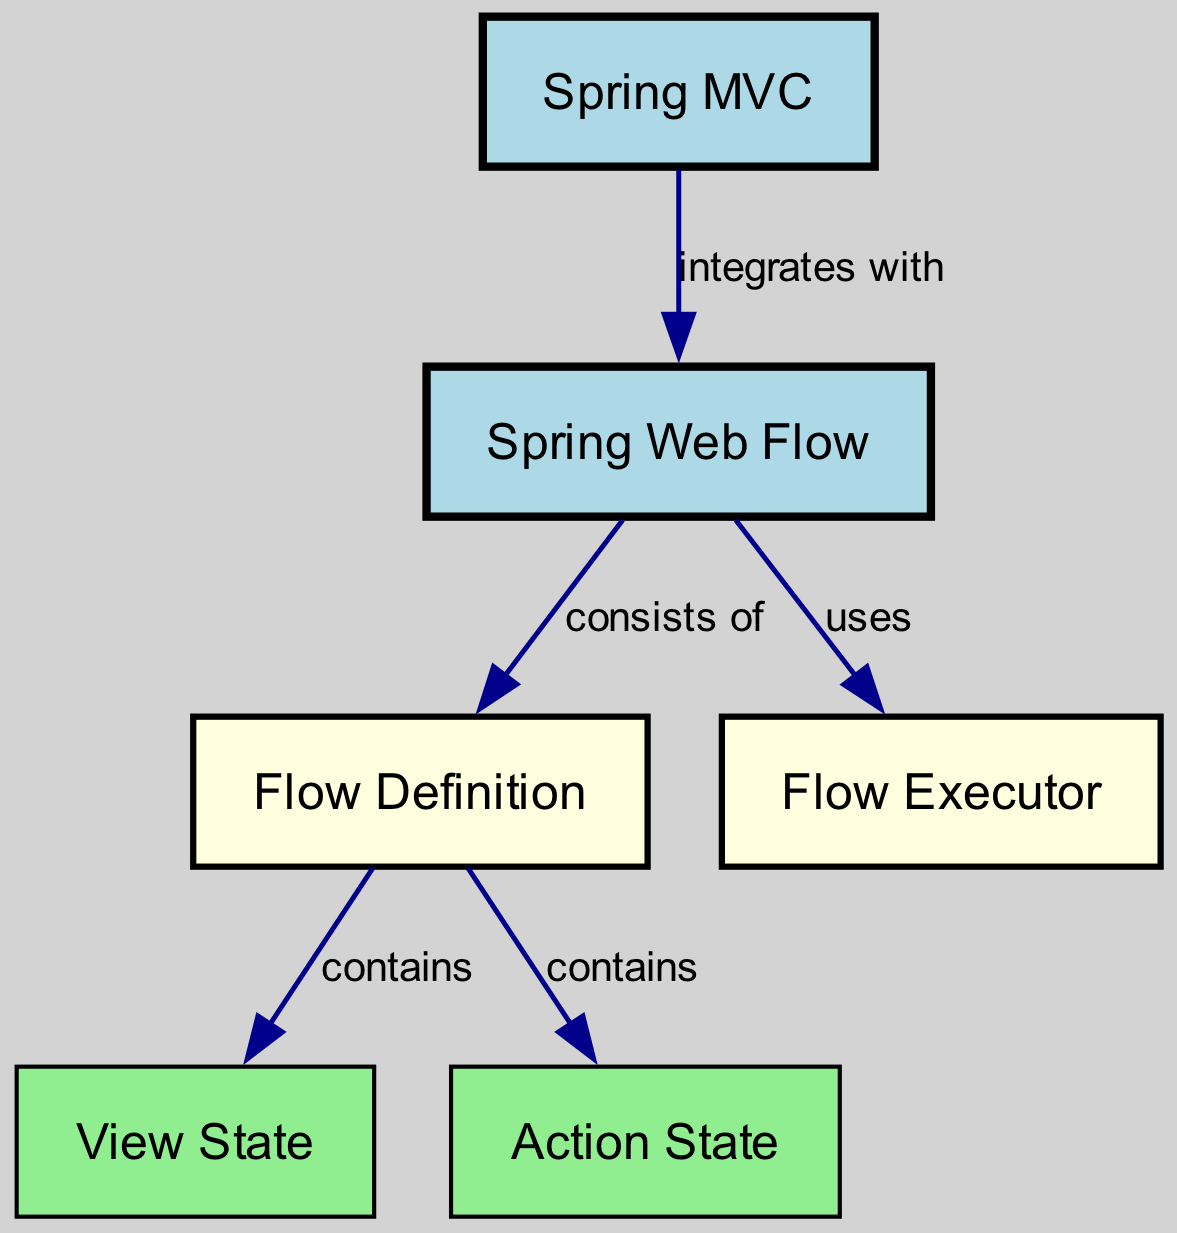What is the main component that integrates with Spring MVC? In the diagram, there is an edge labeled "integrates with" that connects the node "Spring MVC" to the node "Spring Web Flow." Hence, the main component that integrates is "Spring Web Flow."
Answer: Spring Web Flow How many nodes are present in the diagram? The diagram lists six nodes: "Spring MVC," "Spring Web Flow," "Flow Definition," "Flow Executor," "View State," and "Action State." Therefore, the total number of nodes is six.
Answer: 6 Which node is contained within the Flow Definition? The diagram shows two edges originating from "Flow Definition," labeled "contains," leading to "View State" and "Action State." Therefore, both "View State" and "Action State" are contained within the "Flow Definition."
Answer: View State and Action State What is the relationship between Spring Web Flow and Flow Executor? There is an edge labeled "uses" that connects "Spring Web Flow" to "Flow Executor." This indicates that Spring Web Flow uses the Flow Executor.
Answer: uses How many edges are there connecting the nodes in the diagram? The diagram outlines five edges that connect various nodes based on the relationships defined in the edges. Therefore, the total number of edges is five.
Answer: 5 What are the key components that Spring Web Flow consists of? The edge connecting "Spring Web Flow" to "Flow Definition" shows that "Flow Definition" is a key component. Since "Flow Definition" also contains "View State" and "Action State," these are key components as well.
Answer: Flow Definition What specific node type uses the Action State? The edge diagram does not explicitly show a node that uses the "Action State"; however, since "Action State" is contained within the "Flow Definition," it can be inferred that it is utilized by this definition.
Answer: Flow Definition 